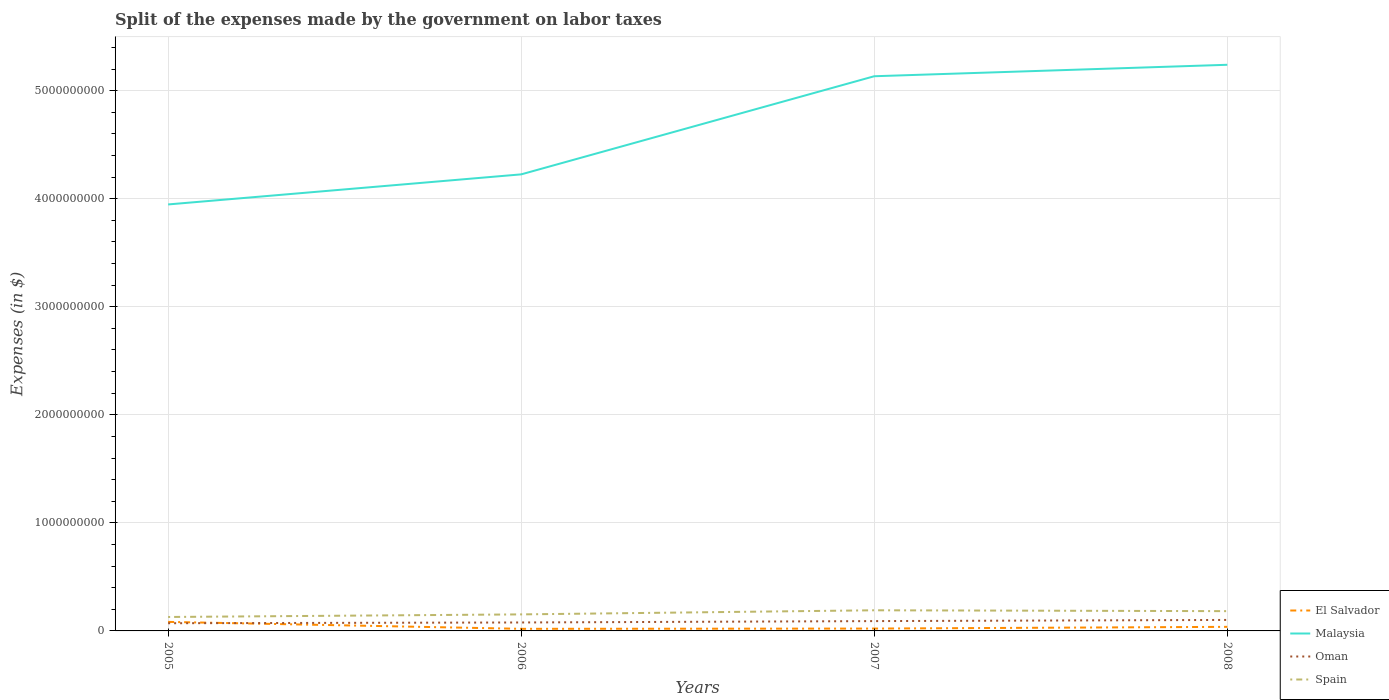Does the line corresponding to Oman intersect with the line corresponding to Malaysia?
Provide a succinct answer. No. Across all years, what is the maximum expenses made by the government on labor taxes in Malaysia?
Your answer should be very brief. 3.95e+09. In which year was the expenses made by the government on labor taxes in Malaysia maximum?
Ensure brevity in your answer.  2005. What is the total expenses made by the government on labor taxes in Malaysia in the graph?
Make the answer very short. -2.78e+08. What is the difference between the highest and the second highest expenses made by the government on labor taxes in Spain?
Your response must be concise. 6.20e+07. How many years are there in the graph?
Provide a short and direct response. 4. How many legend labels are there?
Your response must be concise. 4. How are the legend labels stacked?
Provide a succinct answer. Vertical. What is the title of the graph?
Provide a short and direct response. Split of the expenses made by the government on labor taxes. What is the label or title of the Y-axis?
Give a very brief answer. Expenses (in $). What is the Expenses (in $) in El Salvador in 2005?
Ensure brevity in your answer.  8.36e+07. What is the Expenses (in $) in Malaysia in 2005?
Your response must be concise. 3.95e+09. What is the Expenses (in $) of Oman in 2005?
Provide a short and direct response. 7.12e+07. What is the Expenses (in $) in Spain in 2005?
Offer a terse response. 1.29e+08. What is the Expenses (in $) in El Salvador in 2006?
Provide a short and direct response. 1.94e+07. What is the Expenses (in $) of Malaysia in 2006?
Keep it short and to the point. 4.23e+09. What is the Expenses (in $) of Oman in 2006?
Your answer should be compact. 7.82e+07. What is the Expenses (in $) in Spain in 2006?
Offer a terse response. 1.53e+08. What is the Expenses (in $) in El Salvador in 2007?
Offer a terse response. 2.18e+07. What is the Expenses (in $) of Malaysia in 2007?
Your answer should be compact. 5.13e+09. What is the Expenses (in $) of Oman in 2007?
Your answer should be very brief. 9.09e+07. What is the Expenses (in $) in Spain in 2007?
Keep it short and to the point. 1.91e+08. What is the Expenses (in $) in El Salvador in 2008?
Offer a terse response. 3.77e+07. What is the Expenses (in $) in Malaysia in 2008?
Keep it short and to the point. 5.24e+09. What is the Expenses (in $) of Oman in 2008?
Provide a short and direct response. 1.02e+08. What is the Expenses (in $) of Spain in 2008?
Your response must be concise. 1.83e+08. Across all years, what is the maximum Expenses (in $) of El Salvador?
Ensure brevity in your answer.  8.36e+07. Across all years, what is the maximum Expenses (in $) of Malaysia?
Your response must be concise. 5.24e+09. Across all years, what is the maximum Expenses (in $) of Oman?
Keep it short and to the point. 1.02e+08. Across all years, what is the maximum Expenses (in $) in Spain?
Keep it short and to the point. 1.91e+08. Across all years, what is the minimum Expenses (in $) in El Salvador?
Ensure brevity in your answer.  1.94e+07. Across all years, what is the minimum Expenses (in $) of Malaysia?
Your answer should be very brief. 3.95e+09. Across all years, what is the minimum Expenses (in $) in Oman?
Provide a short and direct response. 7.12e+07. Across all years, what is the minimum Expenses (in $) of Spain?
Your answer should be compact. 1.29e+08. What is the total Expenses (in $) in El Salvador in the graph?
Provide a succinct answer. 1.62e+08. What is the total Expenses (in $) of Malaysia in the graph?
Your answer should be compact. 1.85e+1. What is the total Expenses (in $) in Oman in the graph?
Make the answer very short. 3.42e+08. What is the total Expenses (in $) of Spain in the graph?
Your answer should be compact. 6.56e+08. What is the difference between the Expenses (in $) of El Salvador in 2005 and that in 2006?
Your answer should be very brief. 6.42e+07. What is the difference between the Expenses (in $) of Malaysia in 2005 and that in 2006?
Keep it short and to the point. -2.78e+08. What is the difference between the Expenses (in $) of Oman in 2005 and that in 2006?
Provide a short and direct response. -7.00e+06. What is the difference between the Expenses (in $) of Spain in 2005 and that in 2006?
Make the answer very short. -2.40e+07. What is the difference between the Expenses (in $) in El Salvador in 2005 and that in 2007?
Your response must be concise. 6.18e+07. What is the difference between the Expenses (in $) of Malaysia in 2005 and that in 2007?
Offer a very short reply. -1.19e+09. What is the difference between the Expenses (in $) in Oman in 2005 and that in 2007?
Your response must be concise. -1.97e+07. What is the difference between the Expenses (in $) in Spain in 2005 and that in 2007?
Offer a very short reply. -6.20e+07. What is the difference between the Expenses (in $) of El Salvador in 2005 and that in 2008?
Your response must be concise. 4.59e+07. What is the difference between the Expenses (in $) in Malaysia in 2005 and that in 2008?
Give a very brief answer. -1.29e+09. What is the difference between the Expenses (in $) of Oman in 2005 and that in 2008?
Keep it short and to the point. -3.05e+07. What is the difference between the Expenses (in $) in Spain in 2005 and that in 2008?
Ensure brevity in your answer.  -5.40e+07. What is the difference between the Expenses (in $) of El Salvador in 2006 and that in 2007?
Your response must be concise. -2.40e+06. What is the difference between the Expenses (in $) of Malaysia in 2006 and that in 2007?
Offer a very short reply. -9.08e+08. What is the difference between the Expenses (in $) in Oman in 2006 and that in 2007?
Your answer should be compact. -1.27e+07. What is the difference between the Expenses (in $) of Spain in 2006 and that in 2007?
Keep it short and to the point. -3.80e+07. What is the difference between the Expenses (in $) in El Salvador in 2006 and that in 2008?
Your answer should be very brief. -1.83e+07. What is the difference between the Expenses (in $) in Malaysia in 2006 and that in 2008?
Provide a short and direct response. -1.01e+09. What is the difference between the Expenses (in $) of Oman in 2006 and that in 2008?
Your response must be concise. -2.35e+07. What is the difference between the Expenses (in $) in Spain in 2006 and that in 2008?
Make the answer very short. -3.00e+07. What is the difference between the Expenses (in $) in El Salvador in 2007 and that in 2008?
Offer a terse response. -1.59e+07. What is the difference between the Expenses (in $) of Malaysia in 2007 and that in 2008?
Ensure brevity in your answer.  -1.06e+08. What is the difference between the Expenses (in $) in Oman in 2007 and that in 2008?
Ensure brevity in your answer.  -1.08e+07. What is the difference between the Expenses (in $) of El Salvador in 2005 and the Expenses (in $) of Malaysia in 2006?
Offer a terse response. -4.14e+09. What is the difference between the Expenses (in $) of El Salvador in 2005 and the Expenses (in $) of Oman in 2006?
Provide a succinct answer. 5.40e+06. What is the difference between the Expenses (in $) of El Salvador in 2005 and the Expenses (in $) of Spain in 2006?
Offer a very short reply. -6.94e+07. What is the difference between the Expenses (in $) in Malaysia in 2005 and the Expenses (in $) in Oman in 2006?
Provide a short and direct response. 3.87e+09. What is the difference between the Expenses (in $) in Malaysia in 2005 and the Expenses (in $) in Spain in 2006?
Make the answer very short. 3.79e+09. What is the difference between the Expenses (in $) in Oman in 2005 and the Expenses (in $) in Spain in 2006?
Your response must be concise. -8.18e+07. What is the difference between the Expenses (in $) of El Salvador in 2005 and the Expenses (in $) of Malaysia in 2007?
Your answer should be compact. -5.05e+09. What is the difference between the Expenses (in $) of El Salvador in 2005 and the Expenses (in $) of Oman in 2007?
Keep it short and to the point. -7.30e+06. What is the difference between the Expenses (in $) in El Salvador in 2005 and the Expenses (in $) in Spain in 2007?
Provide a succinct answer. -1.07e+08. What is the difference between the Expenses (in $) of Malaysia in 2005 and the Expenses (in $) of Oman in 2007?
Offer a very short reply. 3.86e+09. What is the difference between the Expenses (in $) of Malaysia in 2005 and the Expenses (in $) of Spain in 2007?
Offer a terse response. 3.76e+09. What is the difference between the Expenses (in $) of Oman in 2005 and the Expenses (in $) of Spain in 2007?
Ensure brevity in your answer.  -1.20e+08. What is the difference between the Expenses (in $) of El Salvador in 2005 and the Expenses (in $) of Malaysia in 2008?
Make the answer very short. -5.16e+09. What is the difference between the Expenses (in $) of El Salvador in 2005 and the Expenses (in $) of Oman in 2008?
Provide a succinct answer. -1.81e+07. What is the difference between the Expenses (in $) in El Salvador in 2005 and the Expenses (in $) in Spain in 2008?
Offer a terse response. -9.94e+07. What is the difference between the Expenses (in $) in Malaysia in 2005 and the Expenses (in $) in Oman in 2008?
Make the answer very short. 3.85e+09. What is the difference between the Expenses (in $) of Malaysia in 2005 and the Expenses (in $) of Spain in 2008?
Your response must be concise. 3.76e+09. What is the difference between the Expenses (in $) in Oman in 2005 and the Expenses (in $) in Spain in 2008?
Give a very brief answer. -1.12e+08. What is the difference between the Expenses (in $) in El Salvador in 2006 and the Expenses (in $) in Malaysia in 2007?
Give a very brief answer. -5.11e+09. What is the difference between the Expenses (in $) of El Salvador in 2006 and the Expenses (in $) of Oman in 2007?
Ensure brevity in your answer.  -7.15e+07. What is the difference between the Expenses (in $) of El Salvador in 2006 and the Expenses (in $) of Spain in 2007?
Provide a succinct answer. -1.72e+08. What is the difference between the Expenses (in $) of Malaysia in 2006 and the Expenses (in $) of Oman in 2007?
Give a very brief answer. 4.13e+09. What is the difference between the Expenses (in $) of Malaysia in 2006 and the Expenses (in $) of Spain in 2007?
Your answer should be compact. 4.03e+09. What is the difference between the Expenses (in $) in Oman in 2006 and the Expenses (in $) in Spain in 2007?
Ensure brevity in your answer.  -1.13e+08. What is the difference between the Expenses (in $) of El Salvador in 2006 and the Expenses (in $) of Malaysia in 2008?
Offer a terse response. -5.22e+09. What is the difference between the Expenses (in $) in El Salvador in 2006 and the Expenses (in $) in Oman in 2008?
Keep it short and to the point. -8.23e+07. What is the difference between the Expenses (in $) in El Salvador in 2006 and the Expenses (in $) in Spain in 2008?
Your response must be concise. -1.64e+08. What is the difference between the Expenses (in $) of Malaysia in 2006 and the Expenses (in $) of Oman in 2008?
Keep it short and to the point. 4.12e+09. What is the difference between the Expenses (in $) of Malaysia in 2006 and the Expenses (in $) of Spain in 2008?
Keep it short and to the point. 4.04e+09. What is the difference between the Expenses (in $) of Oman in 2006 and the Expenses (in $) of Spain in 2008?
Offer a terse response. -1.05e+08. What is the difference between the Expenses (in $) in El Salvador in 2007 and the Expenses (in $) in Malaysia in 2008?
Offer a terse response. -5.22e+09. What is the difference between the Expenses (in $) in El Salvador in 2007 and the Expenses (in $) in Oman in 2008?
Offer a terse response. -7.99e+07. What is the difference between the Expenses (in $) of El Salvador in 2007 and the Expenses (in $) of Spain in 2008?
Your answer should be very brief. -1.61e+08. What is the difference between the Expenses (in $) of Malaysia in 2007 and the Expenses (in $) of Oman in 2008?
Provide a short and direct response. 5.03e+09. What is the difference between the Expenses (in $) in Malaysia in 2007 and the Expenses (in $) in Spain in 2008?
Offer a very short reply. 4.95e+09. What is the difference between the Expenses (in $) in Oman in 2007 and the Expenses (in $) in Spain in 2008?
Make the answer very short. -9.21e+07. What is the average Expenses (in $) in El Salvador per year?
Give a very brief answer. 4.06e+07. What is the average Expenses (in $) in Malaysia per year?
Provide a succinct answer. 4.64e+09. What is the average Expenses (in $) of Oman per year?
Offer a very short reply. 8.55e+07. What is the average Expenses (in $) of Spain per year?
Offer a terse response. 1.64e+08. In the year 2005, what is the difference between the Expenses (in $) in El Salvador and Expenses (in $) in Malaysia?
Make the answer very short. -3.86e+09. In the year 2005, what is the difference between the Expenses (in $) in El Salvador and Expenses (in $) in Oman?
Provide a succinct answer. 1.24e+07. In the year 2005, what is the difference between the Expenses (in $) of El Salvador and Expenses (in $) of Spain?
Keep it short and to the point. -4.54e+07. In the year 2005, what is the difference between the Expenses (in $) of Malaysia and Expenses (in $) of Oman?
Offer a very short reply. 3.88e+09. In the year 2005, what is the difference between the Expenses (in $) in Malaysia and Expenses (in $) in Spain?
Your answer should be very brief. 3.82e+09. In the year 2005, what is the difference between the Expenses (in $) of Oman and Expenses (in $) of Spain?
Make the answer very short. -5.78e+07. In the year 2006, what is the difference between the Expenses (in $) of El Salvador and Expenses (in $) of Malaysia?
Provide a succinct answer. -4.21e+09. In the year 2006, what is the difference between the Expenses (in $) in El Salvador and Expenses (in $) in Oman?
Provide a succinct answer. -5.88e+07. In the year 2006, what is the difference between the Expenses (in $) in El Salvador and Expenses (in $) in Spain?
Provide a succinct answer. -1.34e+08. In the year 2006, what is the difference between the Expenses (in $) in Malaysia and Expenses (in $) in Oman?
Provide a short and direct response. 4.15e+09. In the year 2006, what is the difference between the Expenses (in $) of Malaysia and Expenses (in $) of Spain?
Offer a very short reply. 4.07e+09. In the year 2006, what is the difference between the Expenses (in $) in Oman and Expenses (in $) in Spain?
Keep it short and to the point. -7.48e+07. In the year 2007, what is the difference between the Expenses (in $) of El Salvador and Expenses (in $) of Malaysia?
Make the answer very short. -5.11e+09. In the year 2007, what is the difference between the Expenses (in $) of El Salvador and Expenses (in $) of Oman?
Your answer should be compact. -6.91e+07. In the year 2007, what is the difference between the Expenses (in $) in El Salvador and Expenses (in $) in Spain?
Make the answer very short. -1.69e+08. In the year 2007, what is the difference between the Expenses (in $) in Malaysia and Expenses (in $) in Oman?
Make the answer very short. 5.04e+09. In the year 2007, what is the difference between the Expenses (in $) of Malaysia and Expenses (in $) of Spain?
Make the answer very short. 4.94e+09. In the year 2007, what is the difference between the Expenses (in $) of Oman and Expenses (in $) of Spain?
Provide a short and direct response. -1.00e+08. In the year 2008, what is the difference between the Expenses (in $) of El Salvador and Expenses (in $) of Malaysia?
Offer a terse response. -5.20e+09. In the year 2008, what is the difference between the Expenses (in $) of El Salvador and Expenses (in $) of Oman?
Offer a terse response. -6.40e+07. In the year 2008, what is the difference between the Expenses (in $) of El Salvador and Expenses (in $) of Spain?
Keep it short and to the point. -1.45e+08. In the year 2008, what is the difference between the Expenses (in $) in Malaysia and Expenses (in $) in Oman?
Offer a very short reply. 5.14e+09. In the year 2008, what is the difference between the Expenses (in $) in Malaysia and Expenses (in $) in Spain?
Provide a succinct answer. 5.06e+09. In the year 2008, what is the difference between the Expenses (in $) of Oman and Expenses (in $) of Spain?
Give a very brief answer. -8.13e+07. What is the ratio of the Expenses (in $) in El Salvador in 2005 to that in 2006?
Provide a succinct answer. 4.31. What is the ratio of the Expenses (in $) in Malaysia in 2005 to that in 2006?
Provide a succinct answer. 0.93. What is the ratio of the Expenses (in $) in Oman in 2005 to that in 2006?
Ensure brevity in your answer.  0.91. What is the ratio of the Expenses (in $) in Spain in 2005 to that in 2006?
Provide a succinct answer. 0.84. What is the ratio of the Expenses (in $) of El Salvador in 2005 to that in 2007?
Provide a short and direct response. 3.83. What is the ratio of the Expenses (in $) of Malaysia in 2005 to that in 2007?
Your answer should be very brief. 0.77. What is the ratio of the Expenses (in $) in Oman in 2005 to that in 2007?
Provide a short and direct response. 0.78. What is the ratio of the Expenses (in $) of Spain in 2005 to that in 2007?
Provide a short and direct response. 0.68. What is the ratio of the Expenses (in $) of El Salvador in 2005 to that in 2008?
Your answer should be compact. 2.22. What is the ratio of the Expenses (in $) of Malaysia in 2005 to that in 2008?
Your answer should be compact. 0.75. What is the ratio of the Expenses (in $) of Oman in 2005 to that in 2008?
Provide a short and direct response. 0.7. What is the ratio of the Expenses (in $) in Spain in 2005 to that in 2008?
Your answer should be compact. 0.7. What is the ratio of the Expenses (in $) of El Salvador in 2006 to that in 2007?
Provide a short and direct response. 0.89. What is the ratio of the Expenses (in $) of Malaysia in 2006 to that in 2007?
Your response must be concise. 0.82. What is the ratio of the Expenses (in $) of Oman in 2006 to that in 2007?
Provide a short and direct response. 0.86. What is the ratio of the Expenses (in $) in Spain in 2006 to that in 2007?
Make the answer very short. 0.8. What is the ratio of the Expenses (in $) of El Salvador in 2006 to that in 2008?
Give a very brief answer. 0.51. What is the ratio of the Expenses (in $) of Malaysia in 2006 to that in 2008?
Give a very brief answer. 0.81. What is the ratio of the Expenses (in $) in Oman in 2006 to that in 2008?
Your answer should be very brief. 0.77. What is the ratio of the Expenses (in $) of Spain in 2006 to that in 2008?
Provide a short and direct response. 0.84. What is the ratio of the Expenses (in $) of El Salvador in 2007 to that in 2008?
Keep it short and to the point. 0.58. What is the ratio of the Expenses (in $) of Malaysia in 2007 to that in 2008?
Your response must be concise. 0.98. What is the ratio of the Expenses (in $) in Oman in 2007 to that in 2008?
Offer a very short reply. 0.89. What is the ratio of the Expenses (in $) in Spain in 2007 to that in 2008?
Keep it short and to the point. 1.04. What is the difference between the highest and the second highest Expenses (in $) of El Salvador?
Make the answer very short. 4.59e+07. What is the difference between the highest and the second highest Expenses (in $) in Malaysia?
Keep it short and to the point. 1.06e+08. What is the difference between the highest and the second highest Expenses (in $) in Oman?
Give a very brief answer. 1.08e+07. What is the difference between the highest and the lowest Expenses (in $) of El Salvador?
Offer a terse response. 6.42e+07. What is the difference between the highest and the lowest Expenses (in $) of Malaysia?
Give a very brief answer. 1.29e+09. What is the difference between the highest and the lowest Expenses (in $) in Oman?
Offer a very short reply. 3.05e+07. What is the difference between the highest and the lowest Expenses (in $) in Spain?
Your answer should be very brief. 6.20e+07. 